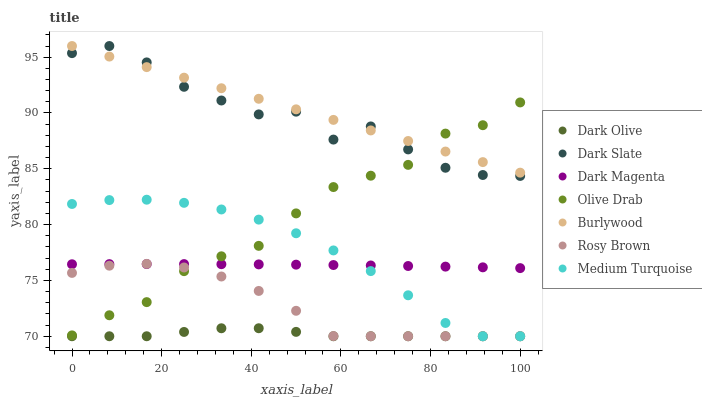Does Dark Olive have the minimum area under the curve?
Answer yes or no. Yes. Does Burlywood have the maximum area under the curve?
Answer yes or no. Yes. Does Dark Magenta have the minimum area under the curve?
Answer yes or no. No. Does Dark Magenta have the maximum area under the curve?
Answer yes or no. No. Is Burlywood the smoothest?
Answer yes or no. Yes. Is Dark Slate the roughest?
Answer yes or no. Yes. Is Dark Magenta the smoothest?
Answer yes or no. No. Is Dark Magenta the roughest?
Answer yes or no. No. Does Dark Olive have the lowest value?
Answer yes or no. Yes. Does Dark Magenta have the lowest value?
Answer yes or no. No. Does Dark Slate have the highest value?
Answer yes or no. Yes. Does Dark Magenta have the highest value?
Answer yes or no. No. Is Medium Turquoise less than Burlywood?
Answer yes or no. Yes. Is Dark Slate greater than Dark Magenta?
Answer yes or no. Yes. Does Dark Olive intersect Medium Turquoise?
Answer yes or no. Yes. Is Dark Olive less than Medium Turquoise?
Answer yes or no. No. Is Dark Olive greater than Medium Turquoise?
Answer yes or no. No. Does Medium Turquoise intersect Burlywood?
Answer yes or no. No. 